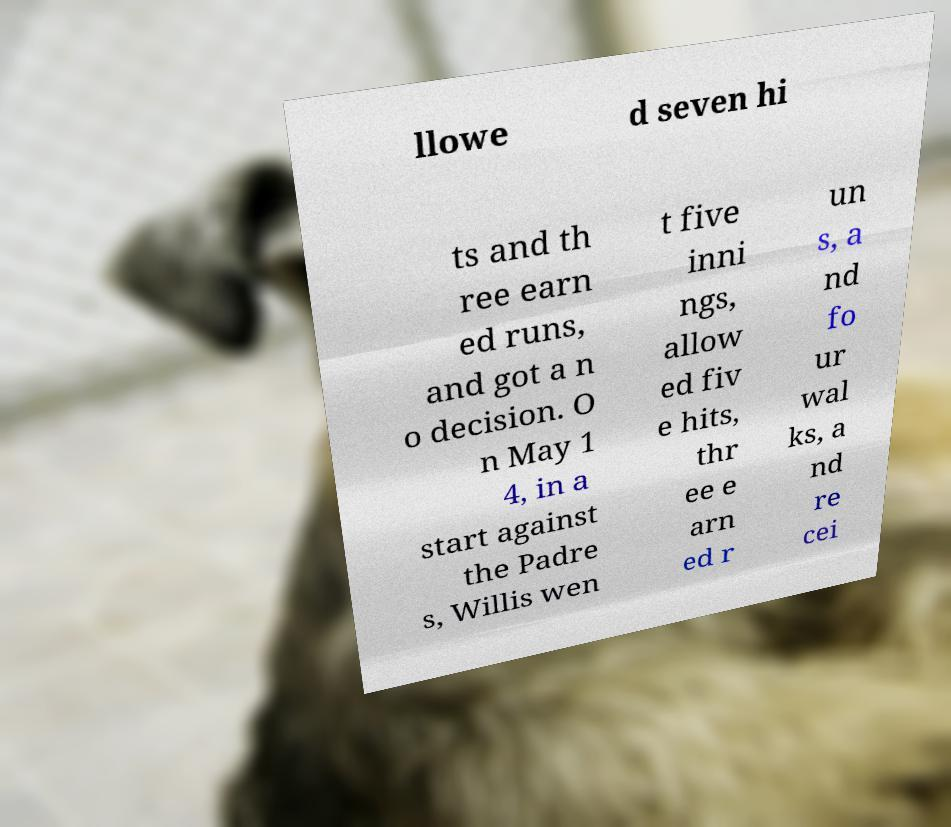Can you accurately transcribe the text from the provided image for me? llowe d seven hi ts and th ree earn ed runs, and got a n o decision. O n May 1 4, in a start against the Padre s, Willis wen t five inni ngs, allow ed fiv e hits, thr ee e arn ed r un s, a nd fo ur wal ks, a nd re cei 